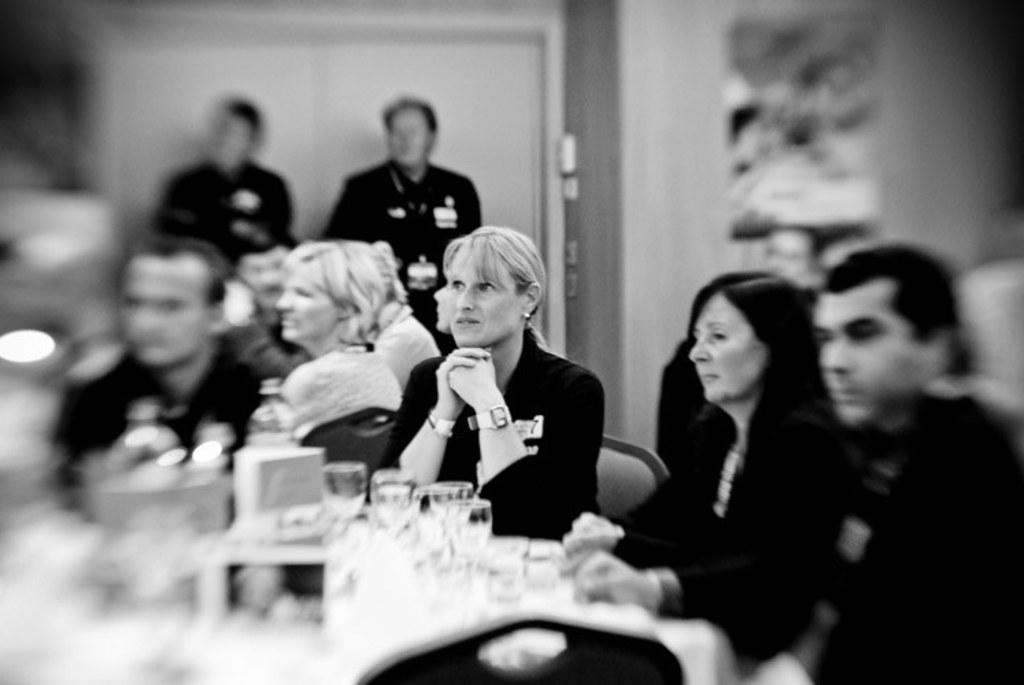In one or two sentences, can you explain what this image depicts? In this image we can see some group of persons sitting on chairs around table and in the background of the image there are two persons standing near the wall, we can see some bottles, glasses and some other items on table. 